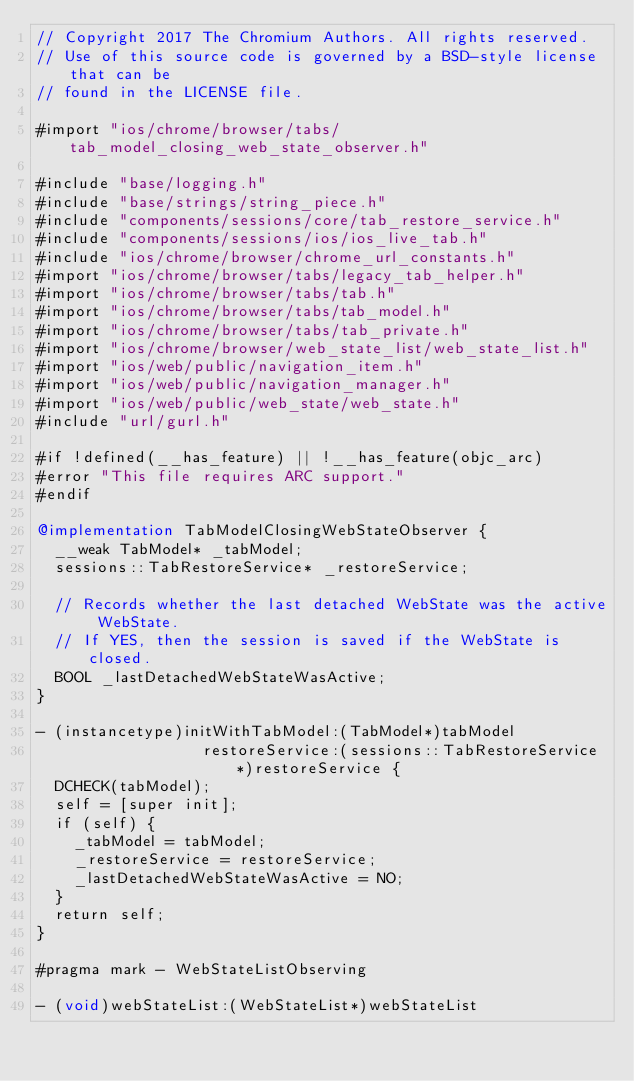Convert code to text. <code><loc_0><loc_0><loc_500><loc_500><_ObjectiveC_>// Copyright 2017 The Chromium Authors. All rights reserved.
// Use of this source code is governed by a BSD-style license that can be
// found in the LICENSE file.

#import "ios/chrome/browser/tabs/tab_model_closing_web_state_observer.h"

#include "base/logging.h"
#include "base/strings/string_piece.h"
#include "components/sessions/core/tab_restore_service.h"
#include "components/sessions/ios/ios_live_tab.h"
#include "ios/chrome/browser/chrome_url_constants.h"
#import "ios/chrome/browser/tabs/legacy_tab_helper.h"
#import "ios/chrome/browser/tabs/tab.h"
#import "ios/chrome/browser/tabs/tab_model.h"
#import "ios/chrome/browser/tabs/tab_private.h"
#import "ios/chrome/browser/web_state_list/web_state_list.h"
#import "ios/web/public/navigation_item.h"
#import "ios/web/public/navigation_manager.h"
#import "ios/web/public/web_state/web_state.h"
#include "url/gurl.h"

#if !defined(__has_feature) || !__has_feature(objc_arc)
#error "This file requires ARC support."
#endif

@implementation TabModelClosingWebStateObserver {
  __weak TabModel* _tabModel;
  sessions::TabRestoreService* _restoreService;

  // Records whether the last detached WebState was the active WebState.
  // If YES, then the session is saved if the WebState is closed.
  BOOL _lastDetachedWebStateWasActive;
}

- (instancetype)initWithTabModel:(TabModel*)tabModel
                  restoreService:(sessions::TabRestoreService*)restoreService {
  DCHECK(tabModel);
  self = [super init];
  if (self) {
    _tabModel = tabModel;
    _restoreService = restoreService;
    _lastDetachedWebStateWasActive = NO;
  }
  return self;
}

#pragma mark - WebStateListObserving

- (void)webStateList:(WebStateList*)webStateList</code> 